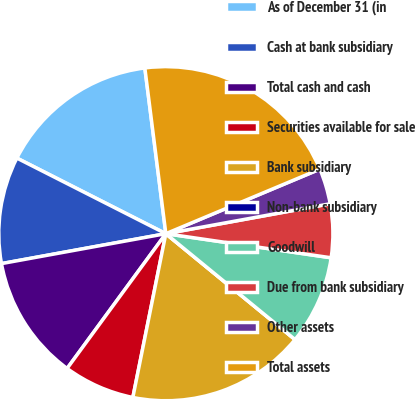Convert chart. <chart><loc_0><loc_0><loc_500><loc_500><pie_chart><fcel>As of December 31 (in<fcel>Cash at bank subsidiary<fcel>Total cash and cash<fcel>Securities available for sale<fcel>Bank subsidiary<fcel>Non-bank subsidiary<fcel>Goodwill<fcel>Due from bank subsidiary<fcel>Other assets<fcel>Total assets<nl><fcel>15.52%<fcel>10.34%<fcel>12.07%<fcel>6.9%<fcel>17.24%<fcel>0.0%<fcel>8.62%<fcel>5.17%<fcel>3.45%<fcel>20.69%<nl></chart> 